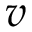Convert formula to latex. <formula><loc_0><loc_0><loc_500><loc_500>v</formula> 